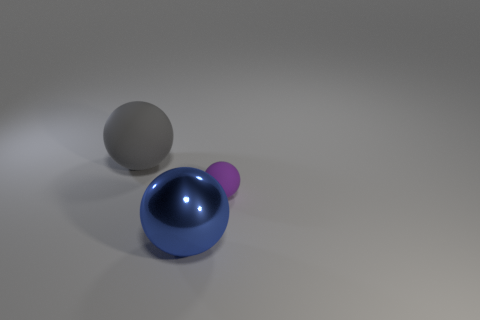Are there any other things that have the same shape as the gray matte thing?
Offer a very short reply. Yes. What number of objects are blue objects or gray rubber objects?
Your answer should be compact. 2. The purple matte thing that is the same shape as the large blue thing is what size?
Give a very brief answer. Small. Is there anything else that is the same size as the purple matte object?
Keep it short and to the point. No. What number of cylinders are either purple rubber things or large blue rubber objects?
Offer a terse response. 0. What is the color of the big thing that is to the right of the object that is left of the blue shiny thing?
Offer a terse response. Blue. The big blue metal object has what shape?
Keep it short and to the point. Sphere. There is a rubber thing that is left of the shiny object; is it the same size as the blue metal thing?
Offer a very short reply. Yes. Are there any large balls that have the same material as the big blue thing?
Your answer should be compact. No. How many objects are either big balls to the right of the big gray matte ball or small blue metallic blocks?
Keep it short and to the point. 1. 